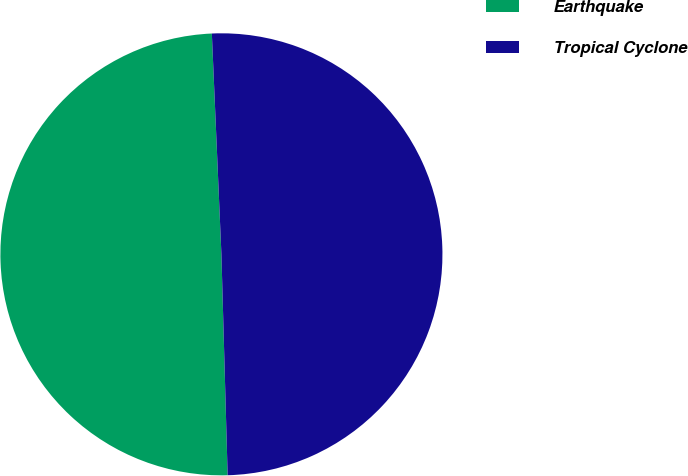<chart> <loc_0><loc_0><loc_500><loc_500><pie_chart><fcel>Earthquake<fcel>Tropical Cyclone<nl><fcel>49.76%<fcel>50.24%<nl></chart> 